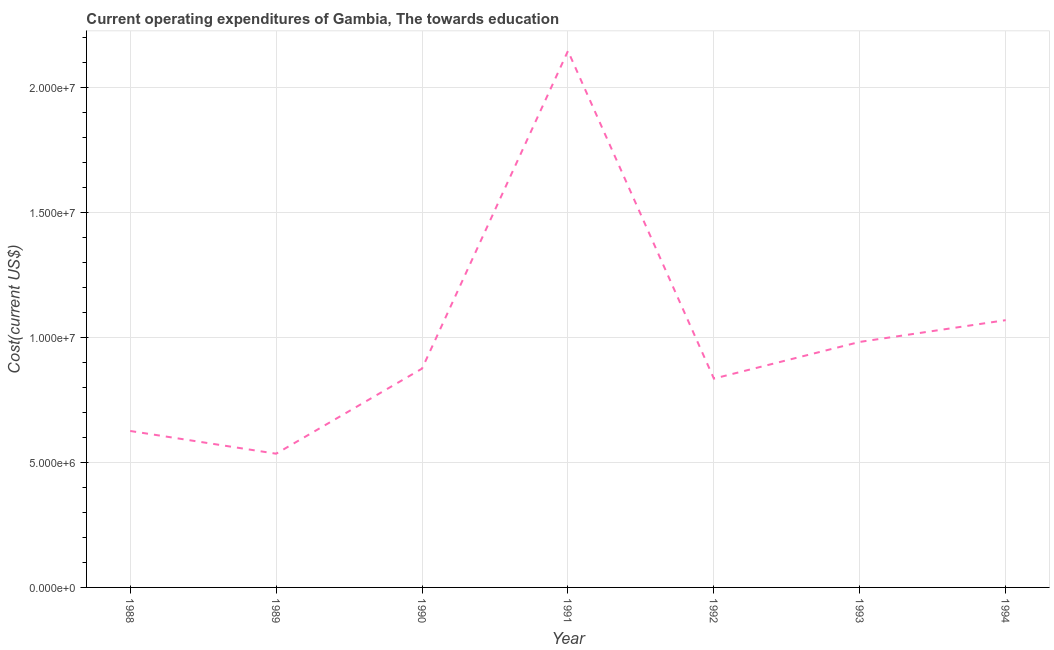What is the education expenditure in 1994?
Offer a terse response. 1.07e+07. Across all years, what is the maximum education expenditure?
Your answer should be very brief. 2.14e+07. Across all years, what is the minimum education expenditure?
Your answer should be compact. 5.35e+06. What is the sum of the education expenditure?
Your response must be concise. 7.06e+07. What is the difference between the education expenditure in 1990 and 1991?
Keep it short and to the point. -1.27e+07. What is the average education expenditure per year?
Your answer should be very brief. 1.01e+07. What is the median education expenditure?
Give a very brief answer. 8.75e+06. Do a majority of the years between 1991 and 1992 (inclusive) have education expenditure greater than 18000000 US$?
Give a very brief answer. No. What is the ratio of the education expenditure in 1990 to that in 1992?
Your answer should be very brief. 1.05. What is the difference between the highest and the second highest education expenditure?
Your response must be concise. 1.08e+07. What is the difference between the highest and the lowest education expenditure?
Your answer should be very brief. 1.61e+07. Does the education expenditure monotonically increase over the years?
Give a very brief answer. No. How many lines are there?
Your answer should be compact. 1. What is the difference between two consecutive major ticks on the Y-axis?
Provide a succinct answer. 5.00e+06. Are the values on the major ticks of Y-axis written in scientific E-notation?
Your answer should be compact. Yes. What is the title of the graph?
Offer a very short reply. Current operating expenditures of Gambia, The towards education. What is the label or title of the Y-axis?
Provide a short and direct response. Cost(current US$). What is the Cost(current US$) of 1988?
Your answer should be compact. 6.25e+06. What is the Cost(current US$) in 1989?
Provide a succinct answer. 5.35e+06. What is the Cost(current US$) in 1990?
Make the answer very short. 8.75e+06. What is the Cost(current US$) of 1991?
Provide a short and direct response. 2.14e+07. What is the Cost(current US$) in 1992?
Your answer should be compact. 8.35e+06. What is the Cost(current US$) of 1993?
Offer a very short reply. 9.81e+06. What is the Cost(current US$) of 1994?
Your answer should be very brief. 1.07e+07. What is the difference between the Cost(current US$) in 1988 and 1989?
Keep it short and to the point. 9.09e+05. What is the difference between the Cost(current US$) in 1988 and 1990?
Offer a very short reply. -2.49e+06. What is the difference between the Cost(current US$) in 1988 and 1991?
Your answer should be very brief. -1.52e+07. What is the difference between the Cost(current US$) in 1988 and 1992?
Give a very brief answer. -2.09e+06. What is the difference between the Cost(current US$) in 1988 and 1993?
Provide a short and direct response. -3.56e+06. What is the difference between the Cost(current US$) in 1988 and 1994?
Give a very brief answer. -4.43e+06. What is the difference between the Cost(current US$) in 1989 and 1990?
Provide a succinct answer. -3.40e+06. What is the difference between the Cost(current US$) in 1989 and 1991?
Make the answer very short. -1.61e+07. What is the difference between the Cost(current US$) in 1989 and 1992?
Your response must be concise. -3.00e+06. What is the difference between the Cost(current US$) in 1989 and 1993?
Keep it short and to the point. -4.47e+06. What is the difference between the Cost(current US$) in 1989 and 1994?
Provide a succinct answer. -5.34e+06. What is the difference between the Cost(current US$) in 1990 and 1991?
Provide a succinct answer. -1.27e+07. What is the difference between the Cost(current US$) in 1990 and 1992?
Provide a short and direct response. 3.99e+05. What is the difference between the Cost(current US$) in 1990 and 1993?
Give a very brief answer. -1.07e+06. What is the difference between the Cost(current US$) in 1990 and 1994?
Offer a terse response. -1.94e+06. What is the difference between the Cost(current US$) in 1991 and 1992?
Your answer should be compact. 1.31e+07. What is the difference between the Cost(current US$) in 1991 and 1993?
Your answer should be compact. 1.16e+07. What is the difference between the Cost(current US$) in 1991 and 1994?
Give a very brief answer. 1.08e+07. What is the difference between the Cost(current US$) in 1992 and 1993?
Offer a very short reply. -1.47e+06. What is the difference between the Cost(current US$) in 1992 and 1994?
Make the answer very short. -2.34e+06. What is the difference between the Cost(current US$) in 1993 and 1994?
Ensure brevity in your answer.  -8.69e+05. What is the ratio of the Cost(current US$) in 1988 to that in 1989?
Offer a very short reply. 1.17. What is the ratio of the Cost(current US$) in 1988 to that in 1990?
Give a very brief answer. 0.71. What is the ratio of the Cost(current US$) in 1988 to that in 1991?
Give a very brief answer. 0.29. What is the ratio of the Cost(current US$) in 1988 to that in 1992?
Offer a very short reply. 0.75. What is the ratio of the Cost(current US$) in 1988 to that in 1993?
Your response must be concise. 0.64. What is the ratio of the Cost(current US$) in 1988 to that in 1994?
Make the answer very short. 0.58. What is the ratio of the Cost(current US$) in 1989 to that in 1990?
Your response must be concise. 0.61. What is the ratio of the Cost(current US$) in 1989 to that in 1991?
Provide a succinct answer. 0.25. What is the ratio of the Cost(current US$) in 1989 to that in 1992?
Offer a very short reply. 0.64. What is the ratio of the Cost(current US$) in 1989 to that in 1993?
Your response must be concise. 0.55. What is the ratio of the Cost(current US$) in 1989 to that in 1994?
Offer a terse response. 0.5. What is the ratio of the Cost(current US$) in 1990 to that in 1991?
Offer a terse response. 0.41. What is the ratio of the Cost(current US$) in 1990 to that in 1992?
Your answer should be very brief. 1.05. What is the ratio of the Cost(current US$) in 1990 to that in 1993?
Offer a very short reply. 0.89. What is the ratio of the Cost(current US$) in 1990 to that in 1994?
Ensure brevity in your answer.  0.82. What is the ratio of the Cost(current US$) in 1991 to that in 1992?
Provide a short and direct response. 2.57. What is the ratio of the Cost(current US$) in 1991 to that in 1993?
Ensure brevity in your answer.  2.19. What is the ratio of the Cost(current US$) in 1991 to that in 1994?
Give a very brief answer. 2.01. What is the ratio of the Cost(current US$) in 1992 to that in 1993?
Make the answer very short. 0.85. What is the ratio of the Cost(current US$) in 1992 to that in 1994?
Make the answer very short. 0.78. What is the ratio of the Cost(current US$) in 1993 to that in 1994?
Your response must be concise. 0.92. 